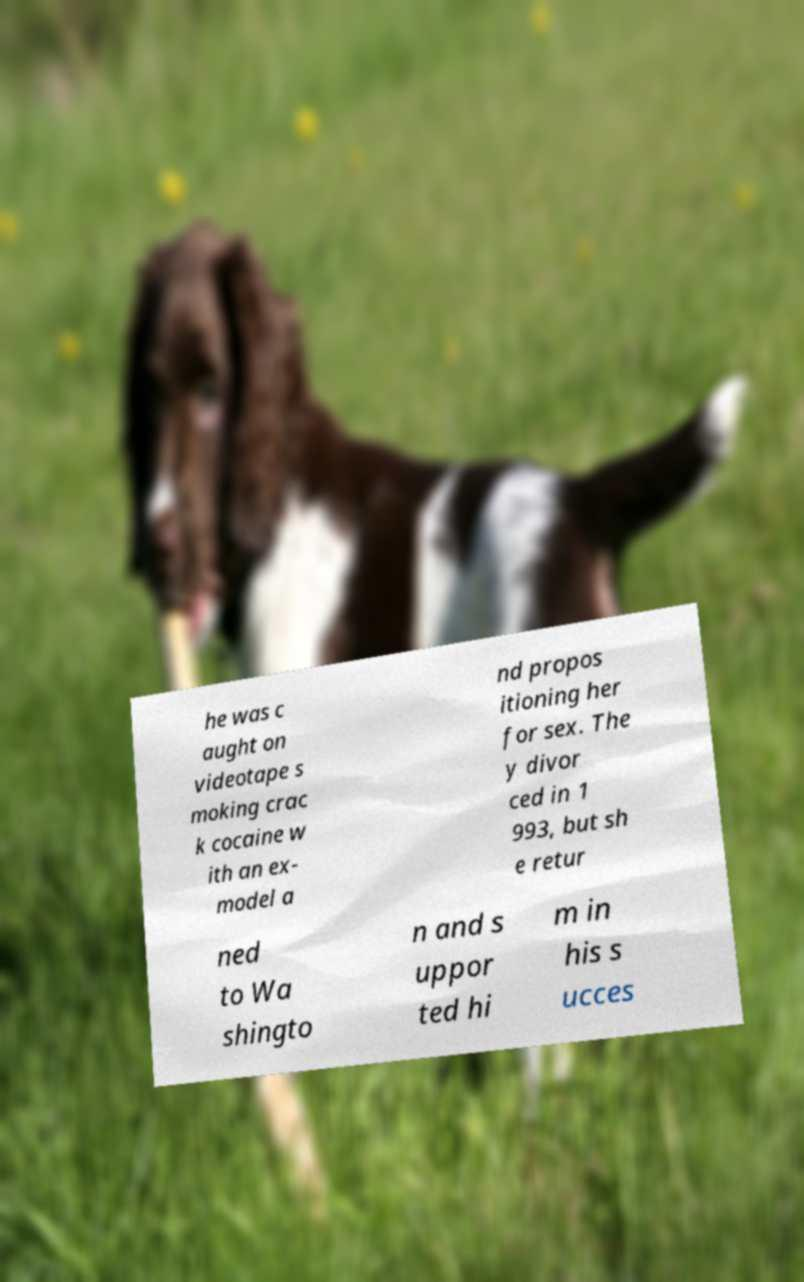There's text embedded in this image that I need extracted. Can you transcribe it verbatim? he was c aught on videotape s moking crac k cocaine w ith an ex- model a nd propos itioning her for sex. The y divor ced in 1 993, but sh e retur ned to Wa shingto n and s uppor ted hi m in his s ucces 